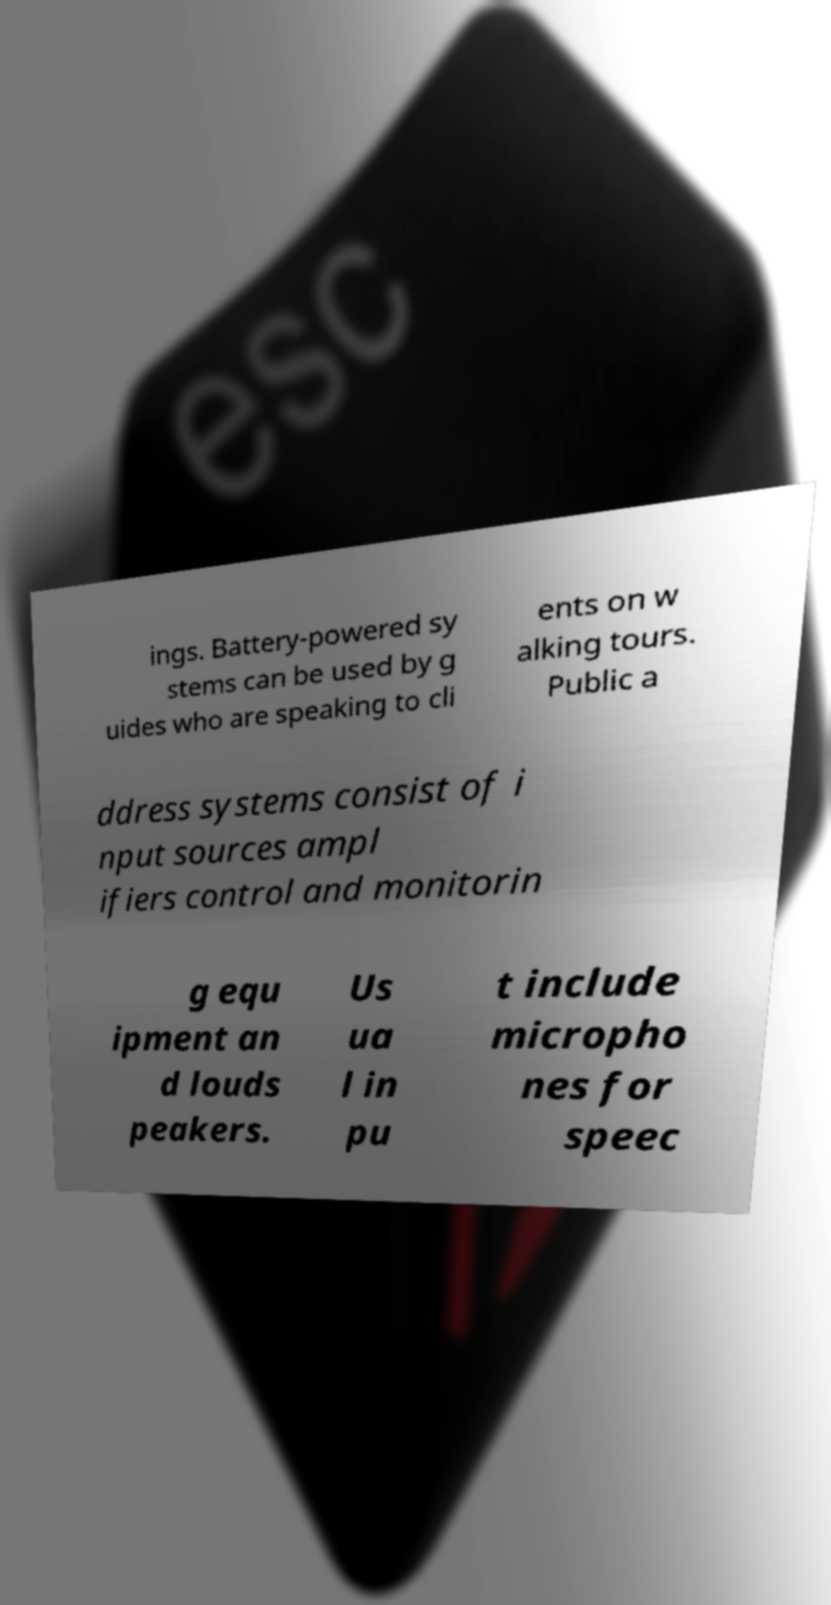Could you extract and type out the text from this image? ings. Battery-powered sy stems can be used by g uides who are speaking to cli ents on w alking tours. Public a ddress systems consist of i nput sources ampl ifiers control and monitorin g equ ipment an d louds peakers. Us ua l in pu t include micropho nes for speec 